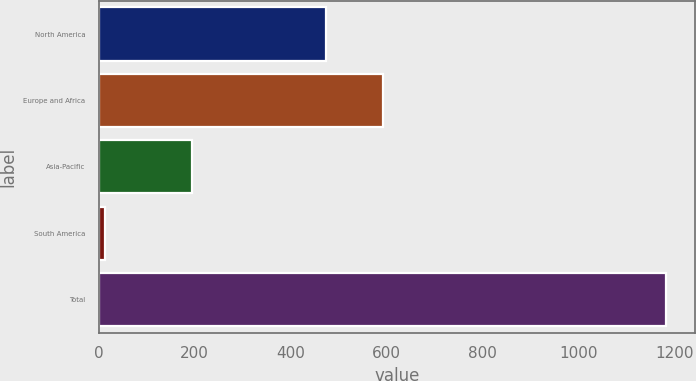Convert chart to OTSL. <chart><loc_0><loc_0><loc_500><loc_500><bar_chart><fcel>North America<fcel>Europe and Africa<fcel>Asia-Pacific<fcel>South America<fcel>Total<nl><fcel>475<fcel>592.1<fcel>194<fcel>13<fcel>1184<nl></chart> 